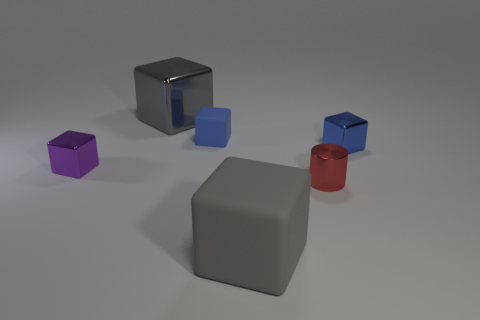Subtract all purple cubes. How many cubes are left? 4 Subtract 2 blocks. How many blocks are left? 3 Subtract all purple shiny blocks. How many blocks are left? 4 Subtract all yellow blocks. Subtract all purple spheres. How many blocks are left? 5 Add 4 small purple shiny blocks. How many objects exist? 10 Subtract all cubes. How many objects are left? 1 Add 4 tiny purple rubber blocks. How many tiny purple rubber blocks exist? 4 Subtract 0 blue cylinders. How many objects are left? 6 Subtract all tiny cyan metal cylinders. Subtract all gray matte objects. How many objects are left? 5 Add 1 cylinders. How many cylinders are left? 2 